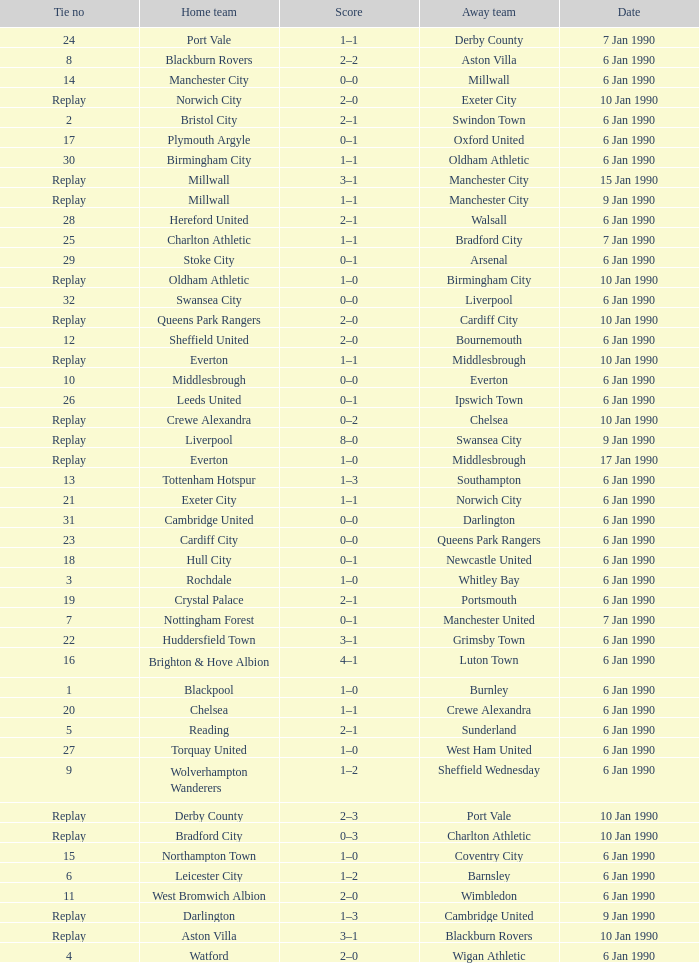What is the score of the game against away team exeter city on 10 jan 1990? 2–0. 